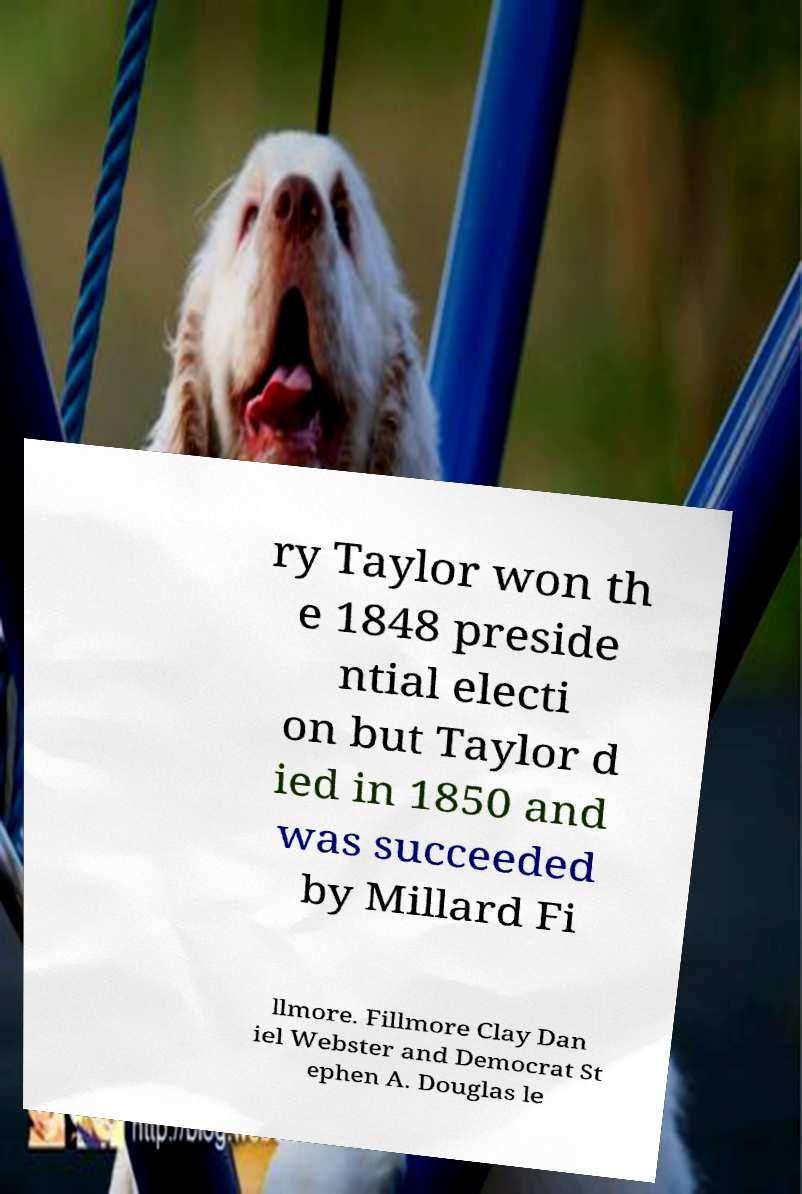I need the written content from this picture converted into text. Can you do that? ry Taylor won th e 1848 preside ntial electi on but Taylor d ied in 1850 and was succeeded by Millard Fi llmore. Fillmore Clay Dan iel Webster and Democrat St ephen A. Douglas le 